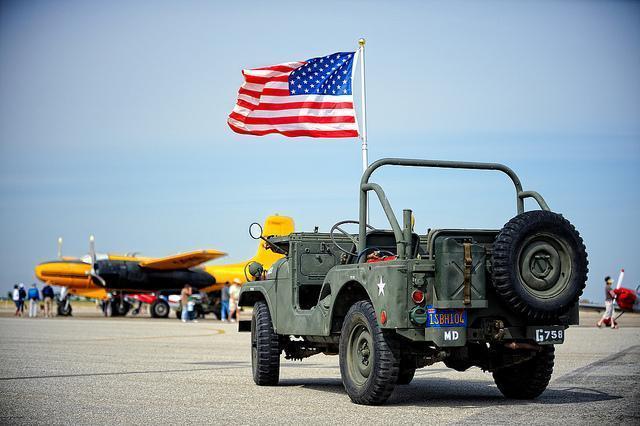Does the image validate the caption "The truck is behind the airplane."?
Answer yes or no. No. Does the caption "The truck is in front of the airplane." correctly depict the image?
Answer yes or no. Yes. 